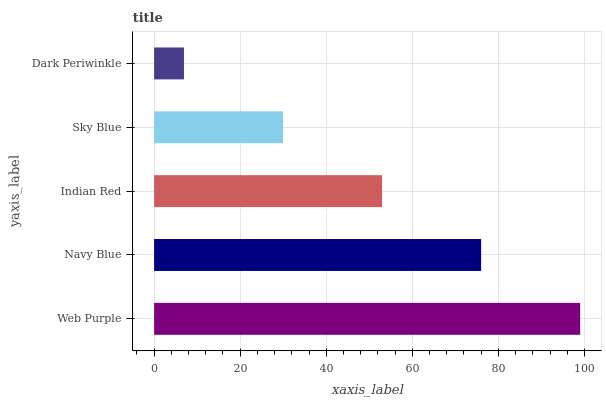Is Dark Periwinkle the minimum?
Answer yes or no. Yes. Is Web Purple the maximum?
Answer yes or no. Yes. Is Navy Blue the minimum?
Answer yes or no. No. Is Navy Blue the maximum?
Answer yes or no. No. Is Web Purple greater than Navy Blue?
Answer yes or no. Yes. Is Navy Blue less than Web Purple?
Answer yes or no. Yes. Is Navy Blue greater than Web Purple?
Answer yes or no. No. Is Web Purple less than Navy Blue?
Answer yes or no. No. Is Indian Red the high median?
Answer yes or no. Yes. Is Indian Red the low median?
Answer yes or no. Yes. Is Dark Periwinkle the high median?
Answer yes or no. No. Is Dark Periwinkle the low median?
Answer yes or no. No. 